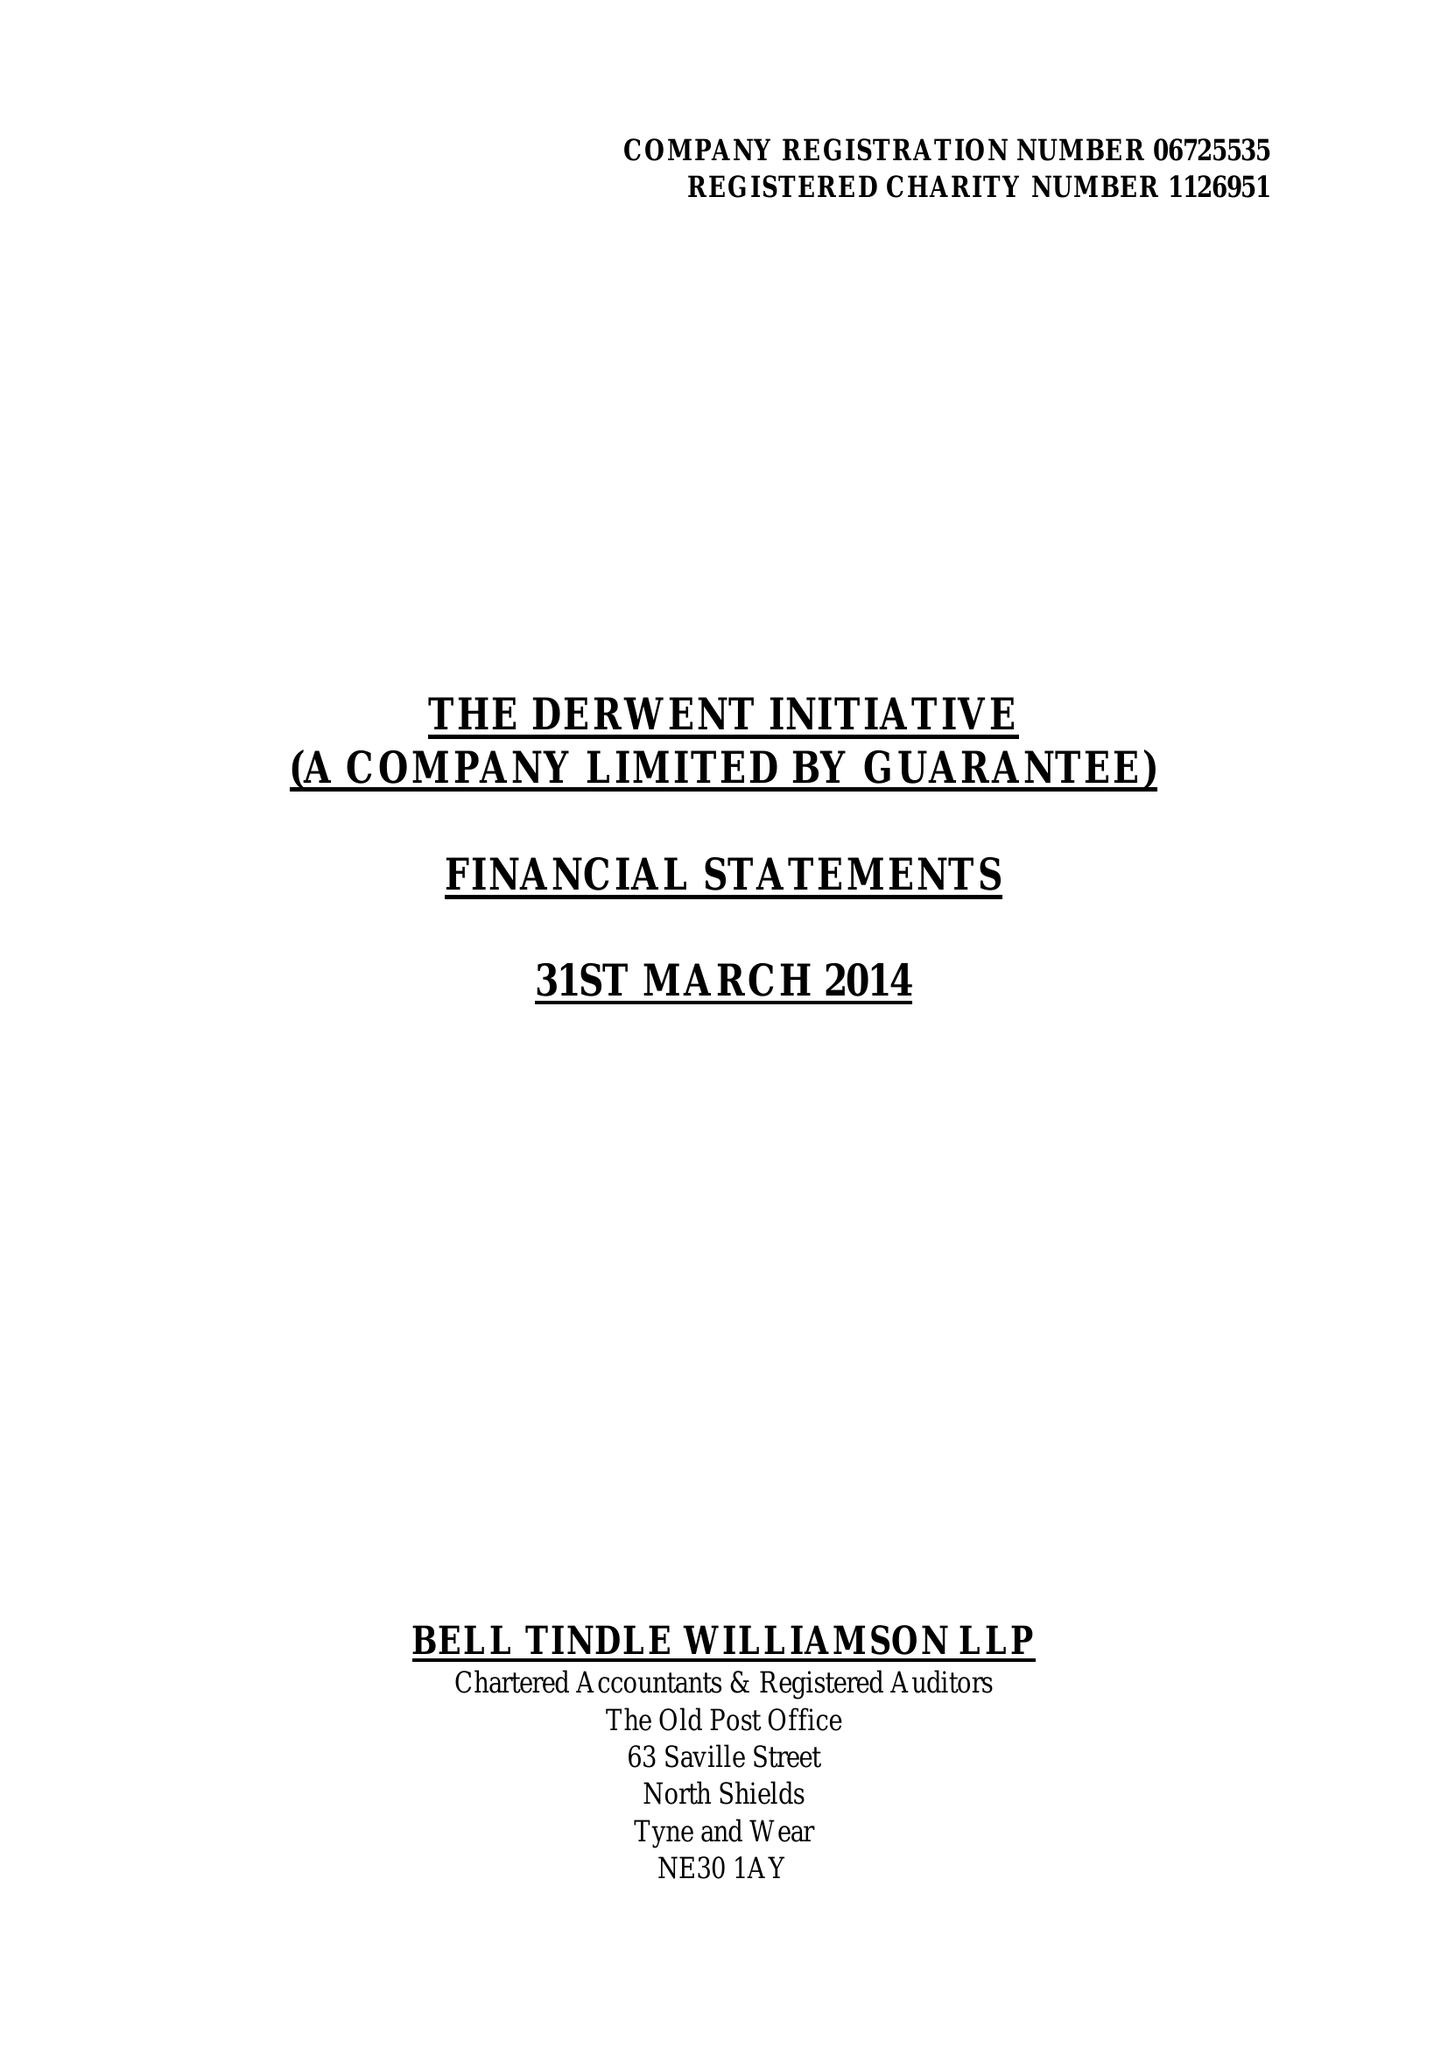What is the value for the address__post_town?
Answer the question using a single word or phrase. NEWCASTLE UPON TYNE 